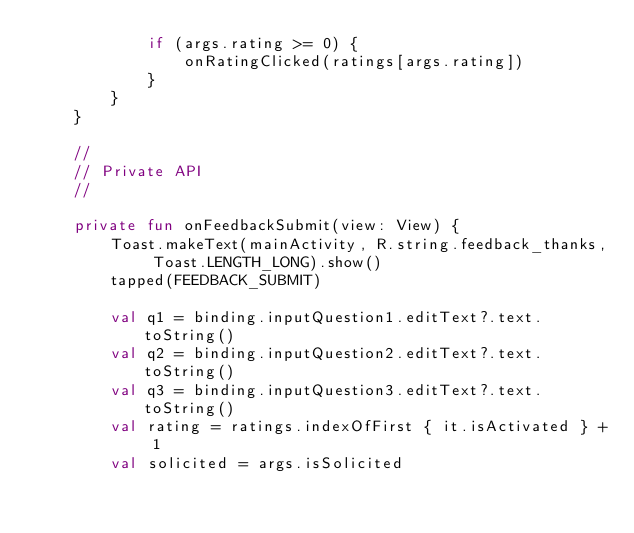Convert code to text. <code><loc_0><loc_0><loc_500><loc_500><_Kotlin_>            if (args.rating >= 0) {
                onRatingClicked(ratings[args.rating])
            }
        }
    }

    //
    // Private API
    //

    private fun onFeedbackSubmit(view: View) {
        Toast.makeText(mainActivity, R.string.feedback_thanks, Toast.LENGTH_LONG).show()
        tapped(FEEDBACK_SUBMIT)

        val q1 = binding.inputQuestion1.editText?.text.toString()
        val q2 = binding.inputQuestion2.editText?.text.toString()
        val q3 = binding.inputQuestion3.editText?.text.toString()
        val rating = ratings.indexOfFirst { it.isActivated } + 1
        val solicited = args.isSolicited
</code> 